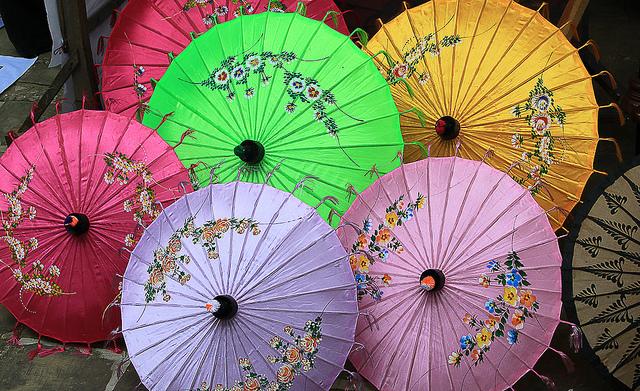What continent are these fans from?
Keep it brief. Asia. How many umbrellas are shown?
Write a very short answer. 7. How many items are in the image?
Give a very brief answer. 7. What are on the umbrellas?
Give a very brief answer. Flowers. Are these items all the same?
Concise answer only. No. 